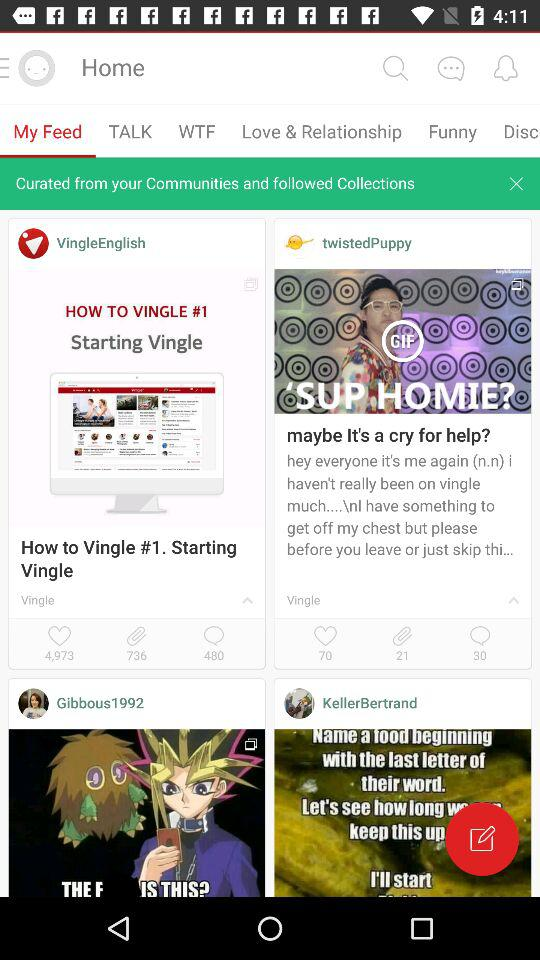How many comments are there on the post by "twistedPuppy"? There are 30 comments. 